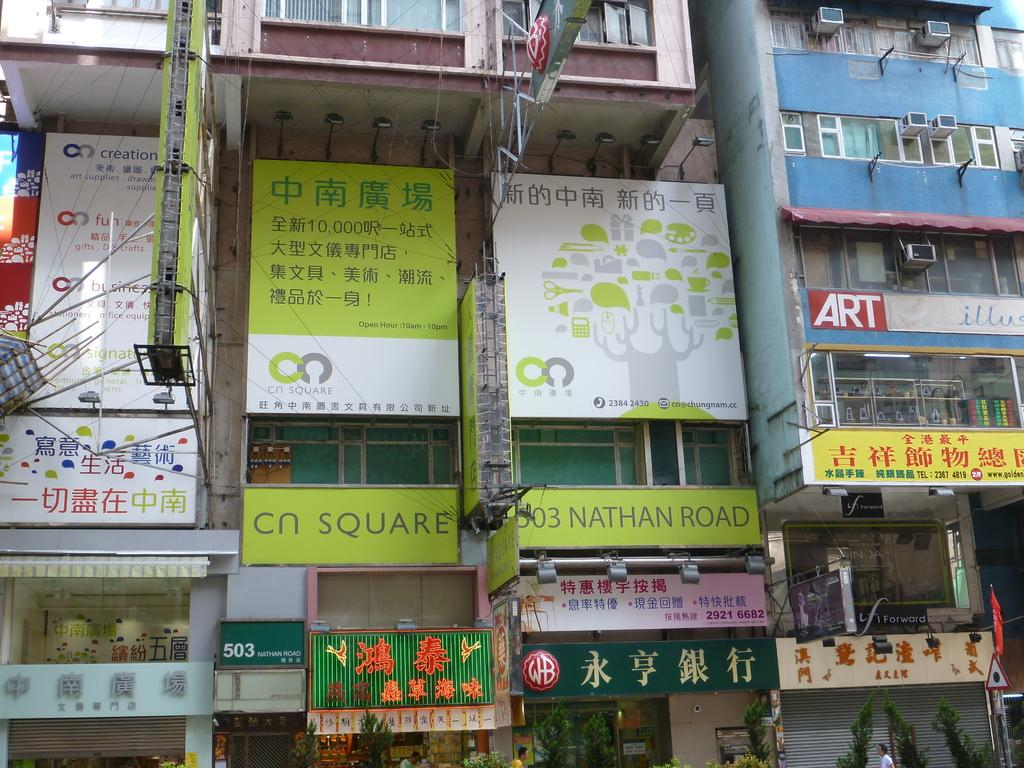<image>
Relay a brief, clear account of the picture shown. The outside of the building that is at 503 Nathan Road. 